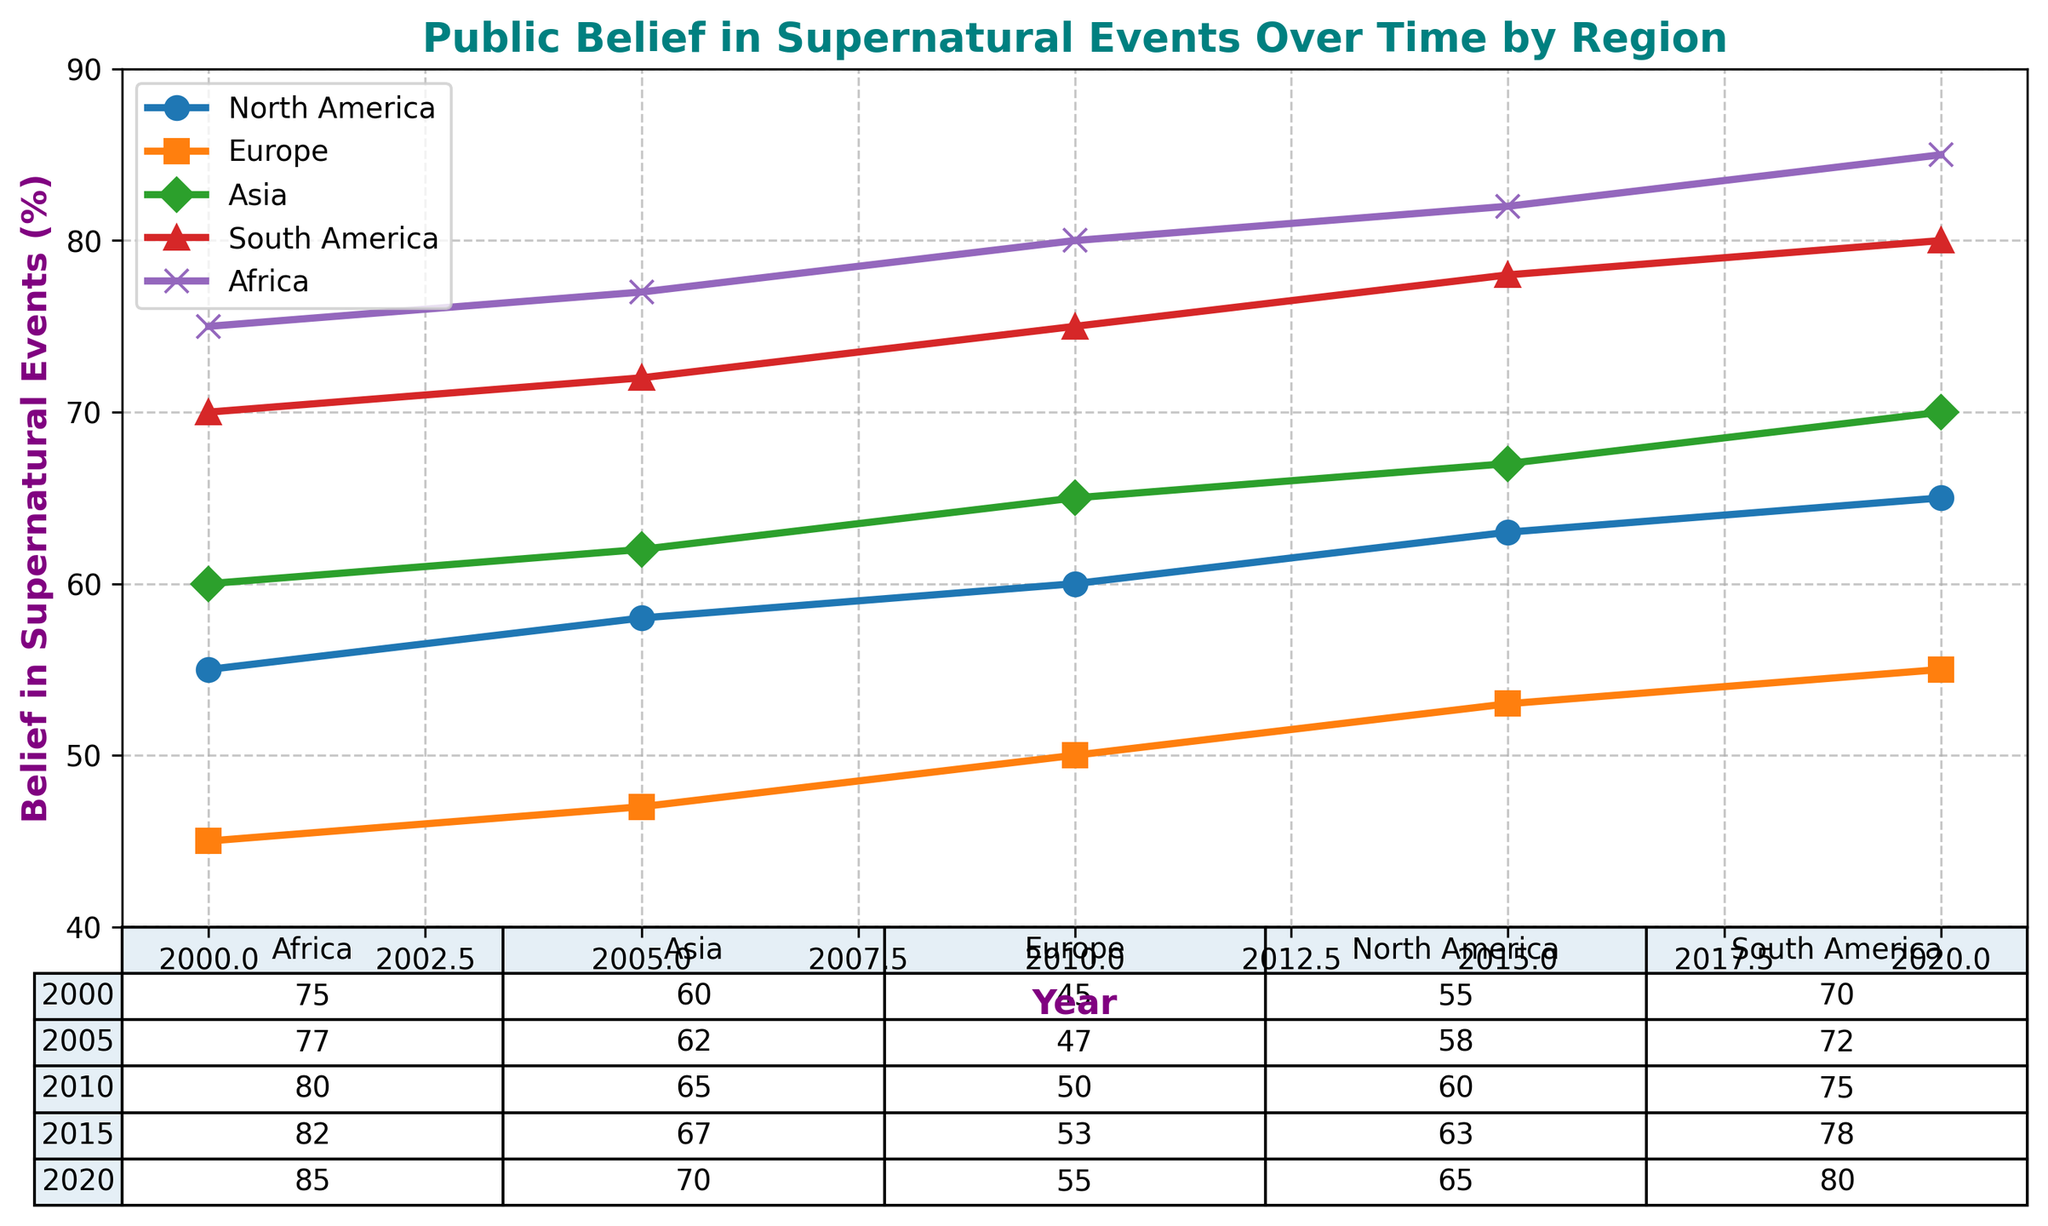What region had the highest belief in supernatural events in the year 2000? North America had a belief percentage of 55%, while Europe had 45%, Asia had 60%, South America had 70%, and Africa had 75%. Among these, Africa had the highest belief.
Answer: Africa From 2000 to 2020, which region showed the greatest increase in belief in supernatural events? For North America, the increase was from 55% to 65%, for Europe from 45% to 55%, for Asia from 60% to 70%, for South America from 70% to 80%, and for Africa from 75% to 85%. The difference for each region is: North America (10%), Europe (10%), Asia (10%), South America (10%), and Africa (10%). Therefore, all regions had equal increases.
Answer: All regions had equal increases Which region had the lowest belief in supernatural events in 2010? The data for 2010 shows the belief percentages as follows: North America - 60%, Europe - 50%, Asia - 65%, South America - 75%, and Africa - 80%. The lowest percentage is in Europe with 50%.
Answer: Europe Comparing the belief percentages between North America and Europe in 2020, by how many percentage points did North America exceed Europe? In 2020, North America's belief percentage was 65%, while Europe's was 55%. Therefore, North America exceeded Europe by 65% - 55% = 10 percentage points.
Answer: 10 percentage points What is the average belief percentage across all regions for the year 2005? In 2005, the belief percentages were: North America - 58%, Europe - 47%, Asia - 62%, South America - 72%, and Africa - 77%. The average is calculated by (58 + 47 + 62 + 72 + 77) / 5 = 316 / 5 = 63.2%.
Answer: 63.2% Which region experienced the smallest change in belief percentage from 2000 to 2020? Calculating the difference from 2000 to 2020 for each region: North America (65% - 55% = 10%), Europe (55% - 45% = 10%), Asia (70% - 60% = 10%), South America (80% - 70% = 10%), and Africa (85% - 75% = 10%). All regions experienced an equal change of 10%.
Answer: All regions had equal changes What is the trend in supernatural belief in Asia from 2000 to 2020? From 2000, the belief percentages in Asia were 60%, increasing to 62% in 2005, 65% in 2010, 67% in 2015, and 70% in 2020. The trend shows a consistent increase over time.
Answer: Increasing In which year did Europe see the belief in supernatural events surpass 50%? The belief percentages for Europe were 45% in 2000, 47% in 2005, 50% in 2010, 53% in 2015, and 55% in 2020. Therefore, the belief surpassed 50% in the year 2015.
Answer: 2015 